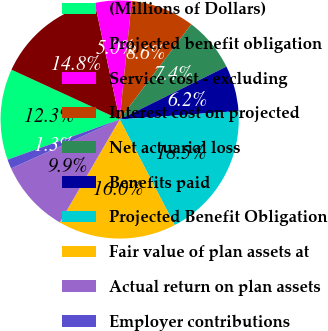Convert chart. <chart><loc_0><loc_0><loc_500><loc_500><pie_chart><fcel>(Millions of Dollars)<fcel>Projected benefit obligation<fcel>Service cost - excluding<fcel>Interest cost on projected<fcel>Net actuarial loss<fcel>Benefits paid<fcel>Projected Benefit Obligation<fcel>Fair value of plan assets at<fcel>Actual return on plan assets<fcel>Employer contributions<nl><fcel>12.34%<fcel>14.79%<fcel>4.96%<fcel>8.65%<fcel>7.42%<fcel>6.19%<fcel>18.48%<fcel>16.02%<fcel>9.88%<fcel>1.27%<nl></chart> 